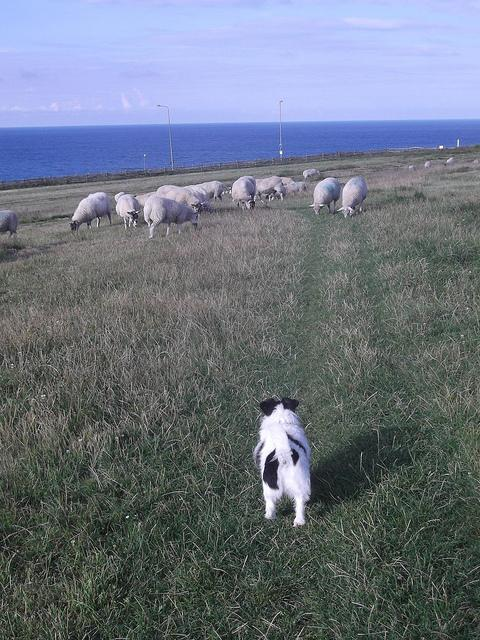What animal is facing the herd? Please explain your reasoning. dog. The dog is facing the herd. 